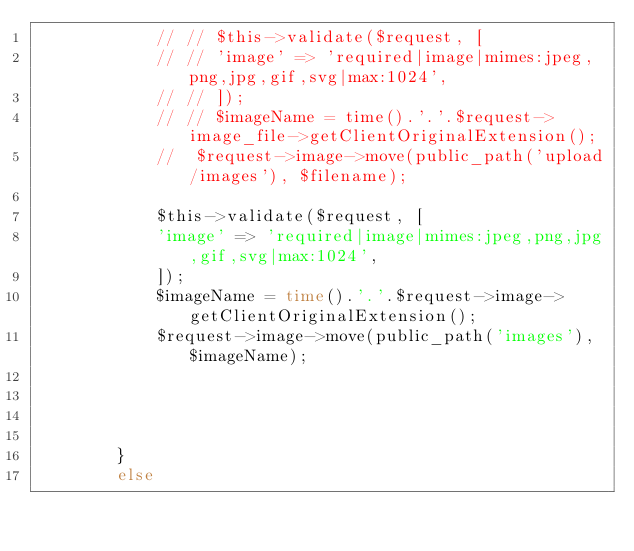<code> <loc_0><loc_0><loc_500><loc_500><_PHP_>            // // $this->validate($request, [
            // // 'image' => 'required|image|mimes:jpeg,png,jpg,gif,svg|max:1024',
            // // ]);
            // // $imageName = time().'.'.$request->image_file->getClientOriginalExtension();
            //  $request->image->move(public_path('upload/images'), $filename);

            $this->validate($request, [
            'image' => 'required|image|mimes:jpeg,png,jpg,gif,svg|max:1024',
            ]);
            $imageName = time().'.'.$request->image->getClientOriginalExtension();
            $request->image->move(public_path('images'), $imageName);




        }
        else</code> 